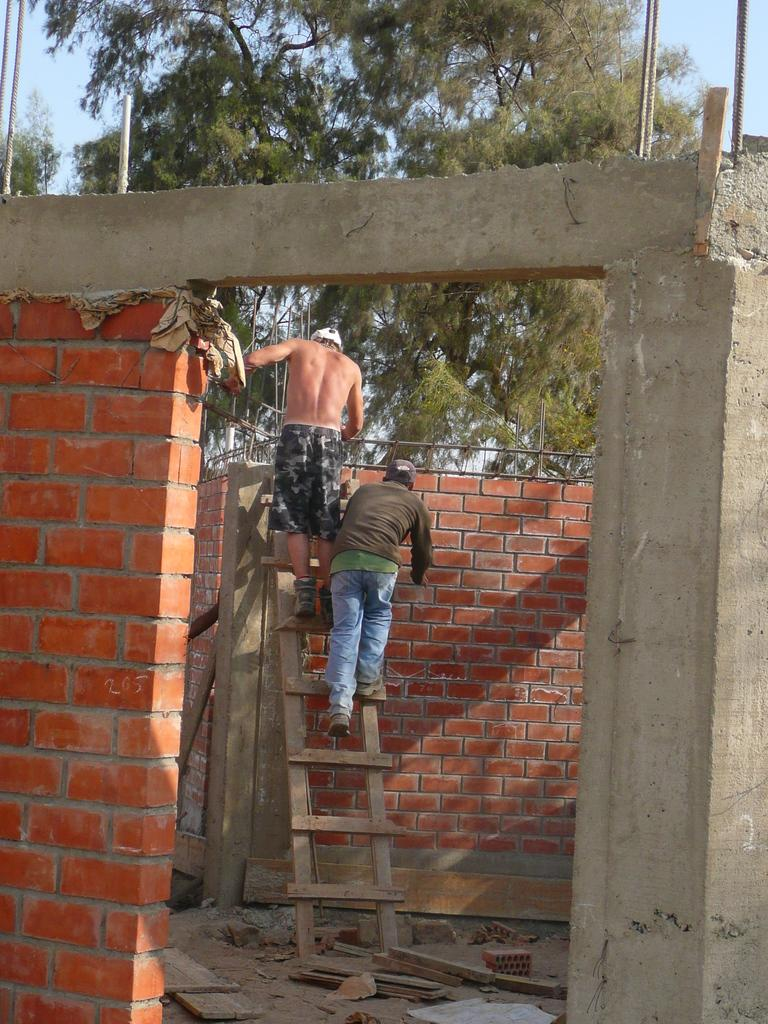How many people are in the image? There are two men in the image. What are the men doing in the image? The men are standing on a ladder. What is the background of the image? There is a brick wall in the image. What type of material is visible in the image? Metal rods are present in the image. What type of vegetation is in the image? There are trees in the image. What type of engine can be seen powering the ladder in the image? There is no engine present in the image, and the ladder is not powered by any engine. 